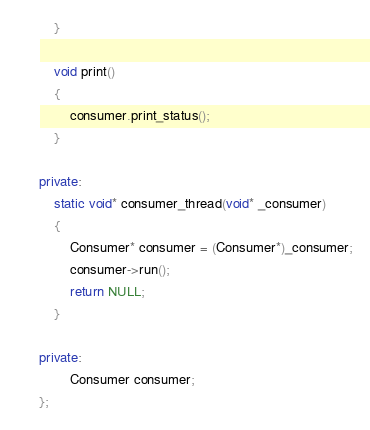Convert code to text. <code><loc_0><loc_0><loc_500><loc_500><_C++_>    }

    void print()
    {
        consumer.print_status();
    }

private:
    static void* consumer_thread(void* _consumer)
    {
        Consumer* consumer = (Consumer*)_consumer;
        consumer->run();
        return NULL;
    }

private:
        Consumer consumer;
};


</code> 